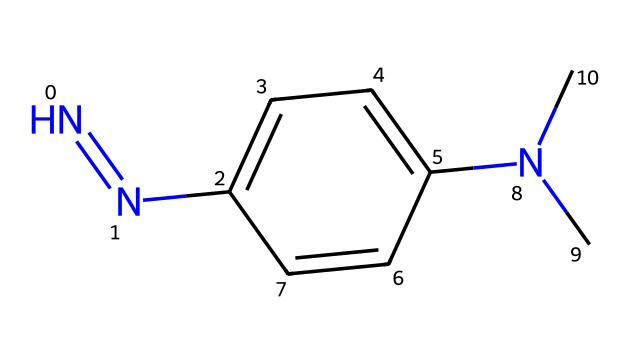what is the total number of nitrogen atoms in this chemical? The chemical structure shows two nitrogen atoms connected with a double bond (N=N) and one nitrogen atom as part of the substituent group (N(C)). Therefore, counting all nitrogen atoms gives a total of three.
Answer: three how many carbon atoms are present in this structure? By analyzing the structure, the main ring contains six carbon atoms, and the two additional carbon atoms come from the N(C) substituent, making a total of eight carbon atoms.
Answer: eight what type of functional groups are present in this molecule? This structure contains an azine (due to N=N) and a tertiary amine (due to the N(C) group), indicating that it has both an azine and an amine functional group.
Answer: azine, amine what is the degree of unsaturation in this compound? The degree of unsaturation can be calculated from the formula: (number of rings + number of double bonds). In this molecule, there is one double bond (N=N) and one ring (the phenyl ring), which gives a degree of unsaturation equal to two.
Answer: two how does the presence of nitrogen affect the color of hydrazine-based ink dyes? The presence of nitrogen atoms, particularly in the hydrazine structure, often allows for complex interactions with other molecules, enhancing the dye's ability to absorb light and produce color.
Answer: enhances color what type of reaction can this hydrazine dye undergo? Hydrazines can undergo reduction reactions due to their nucleophilic nature, allowing them to react with electrophiles, which is typical of many azo compounds.
Answer: reduction reactions is this compound likely to be soluble in water? Due to the presence of both nitrogen atoms and the amine functional group, the compound is expected to have good solubility in water because of hydrogen bonding potential.
Answer: likely solubile 